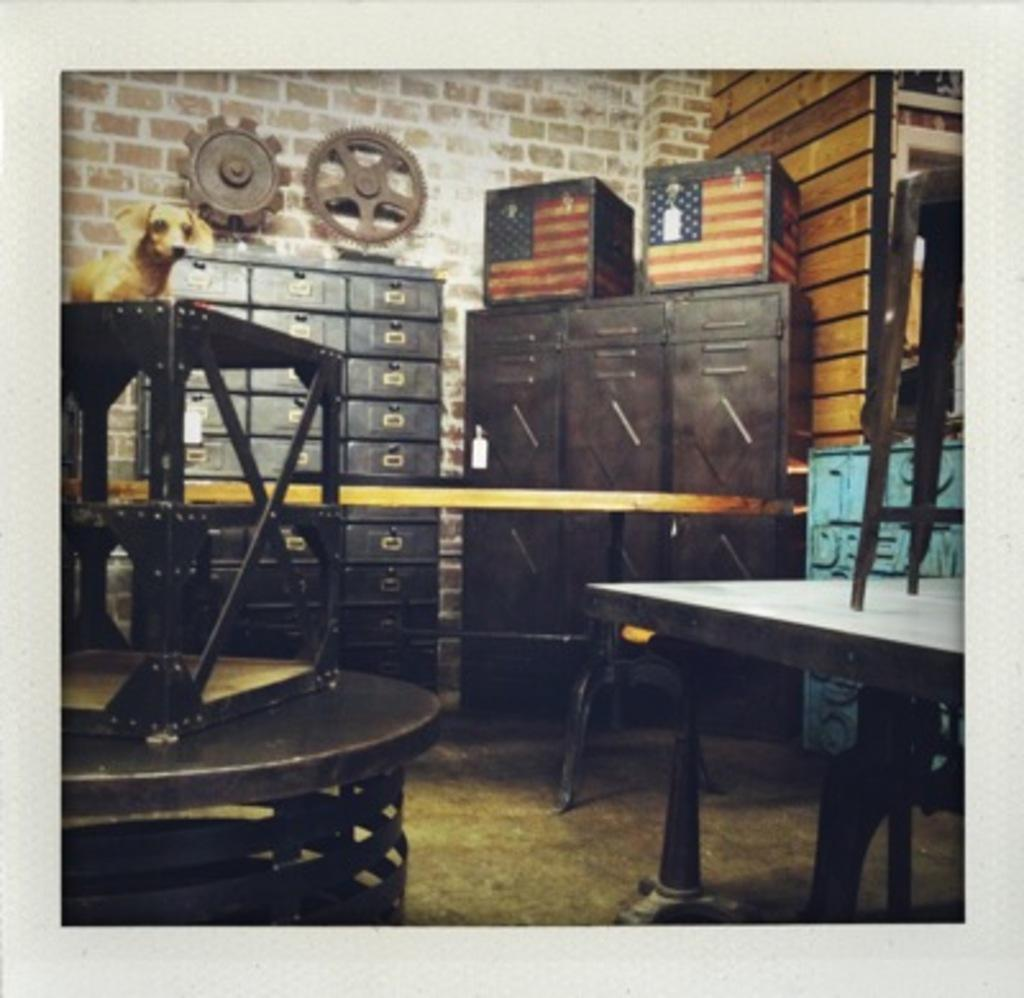What type of objects can be found in the room? There is furniture in the room. What is placed on top of the furniture? There is a dog toy on top of the furniture. What can be seen in the background of the image? There is a wall in the background of the image. How many holes are visible in the dog toy? There is no information about the number of holes in the dog toy, as the facts provided do not mention any holes. 